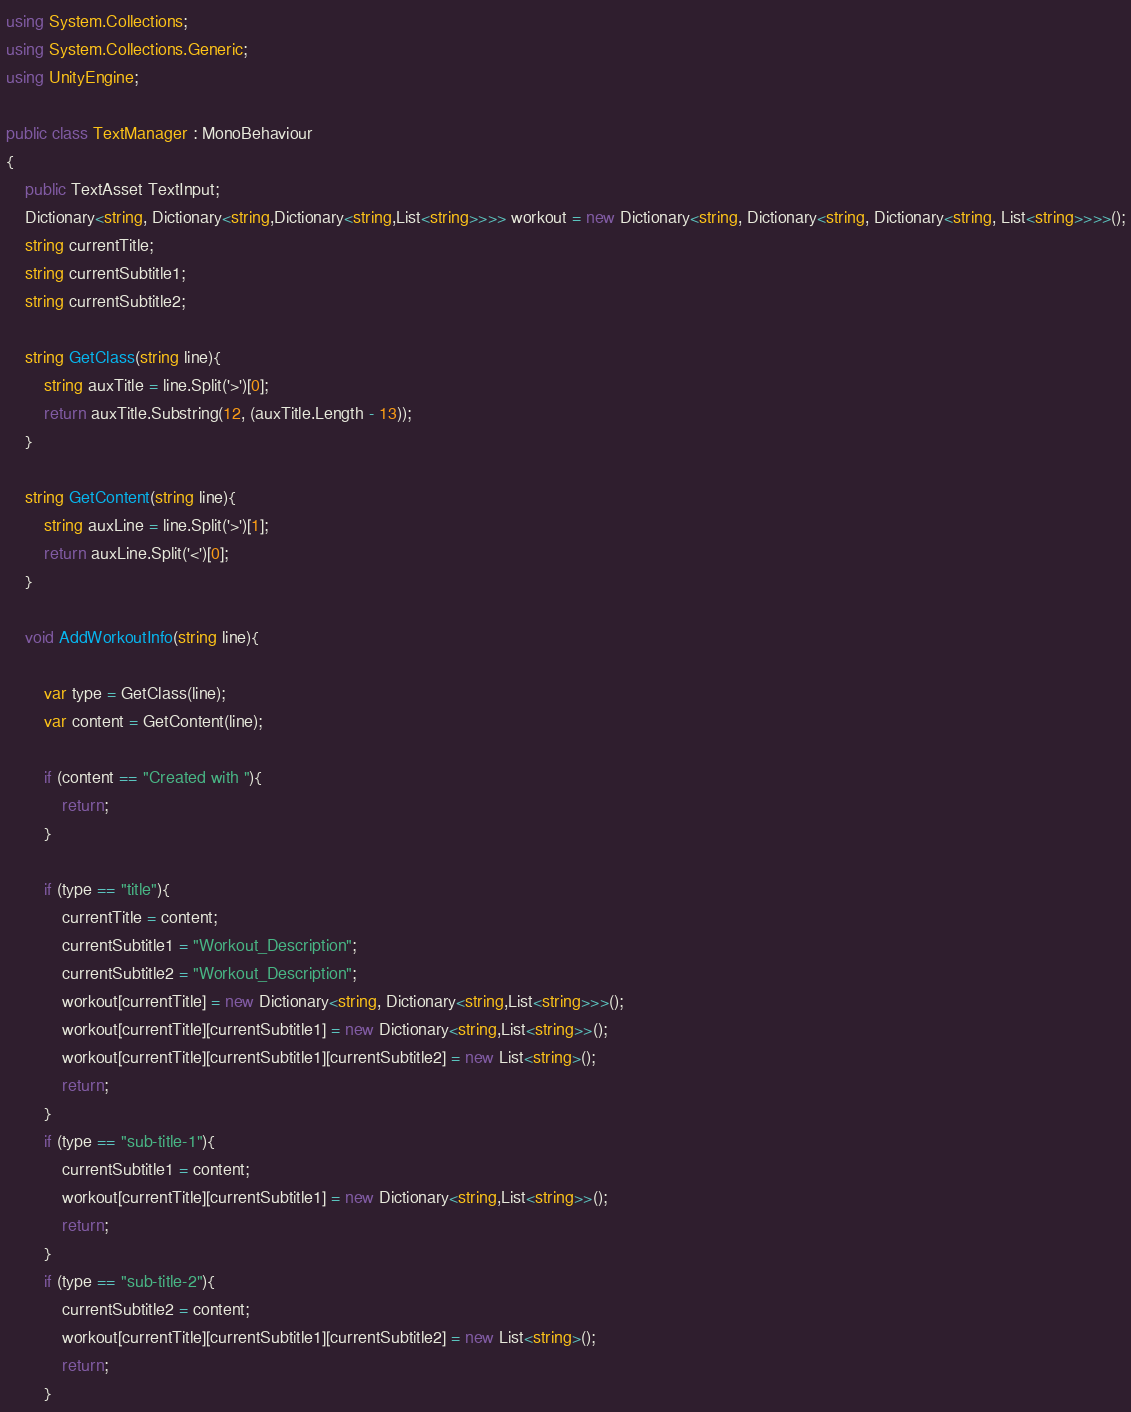<code> <loc_0><loc_0><loc_500><loc_500><_C#_>using System.Collections;
using System.Collections.Generic;
using UnityEngine;

public class TextManager : MonoBehaviour
{
    public TextAsset TextInput;
    Dictionary<string, Dictionary<string,Dictionary<string,List<string>>>> workout = new Dictionary<string, Dictionary<string, Dictionary<string, List<string>>>>();
    string currentTitle;
    string currentSubtitle1;
    string currentSubtitle2;

    string GetClass(string line){
        string auxTitle = line.Split('>')[0];
        return auxTitle.Substring(12, (auxTitle.Length - 13));
    }

    string GetContent(string line){
        string auxLine = line.Split('>')[1];
        return auxLine.Split('<')[0];
    }

    void AddWorkoutInfo(string line){

        var type = GetClass(line);
        var content = GetContent(line);

        if (content == "Created with "){
            return;
        }

        if (type == "title"){
            currentTitle = content;
            currentSubtitle1 = "Workout_Description";
            currentSubtitle2 = "Workout_Description";
            workout[currentTitle] = new Dictionary<string, Dictionary<string,List<string>>>();
            workout[currentTitle][currentSubtitle1] = new Dictionary<string,List<string>>();
            workout[currentTitle][currentSubtitle1][currentSubtitle2] = new List<string>();
            return;
        }
        if (type == "sub-title-1"){
            currentSubtitle1 = content;
            workout[currentTitle][currentSubtitle1] = new Dictionary<string,List<string>>();
            return;
        }
        if (type == "sub-title-2"){
            currentSubtitle2 = content;
            workout[currentTitle][currentSubtitle1][currentSubtitle2] = new List<string>();
            return;
        }</code> 